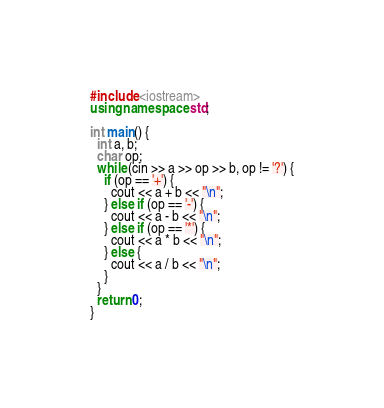<code> <loc_0><loc_0><loc_500><loc_500><_C++_>#include <iostream>
using namespace std;

int main() {
  int a, b;
  char op;
  while (cin >> a >> op >> b, op != '?') {
    if (op == '+') {
      cout << a + b << "\n";
    } else if (op == '-') {
      cout << a - b << "\n";
    } else if (op == '*') {
      cout << a * b << "\n";
    } else {
      cout << a / b << "\n";
    }
  }
  return 0;
}
</code> 